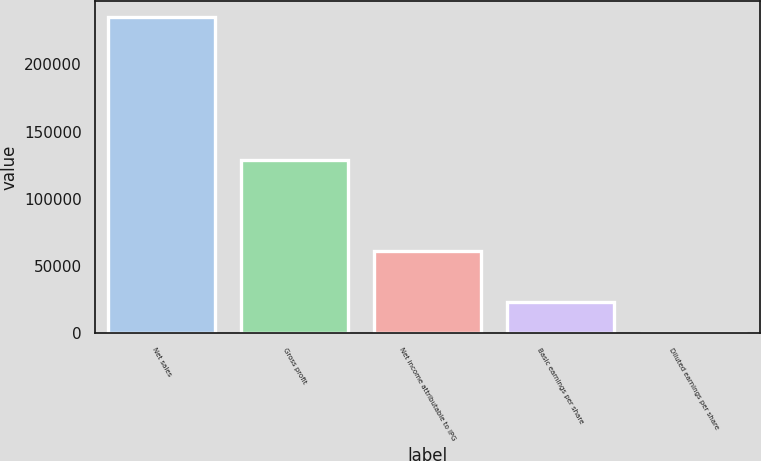Convert chart to OTSL. <chart><loc_0><loc_0><loc_500><loc_500><bar_chart><fcel>Net sales<fcel>Gross profit<fcel>Net income attributable to IPG<fcel>Basic earnings per share<fcel>Diluted earnings per share<nl><fcel>235138<fcel>128703<fcel>61299<fcel>23514.8<fcel>1.15<nl></chart> 